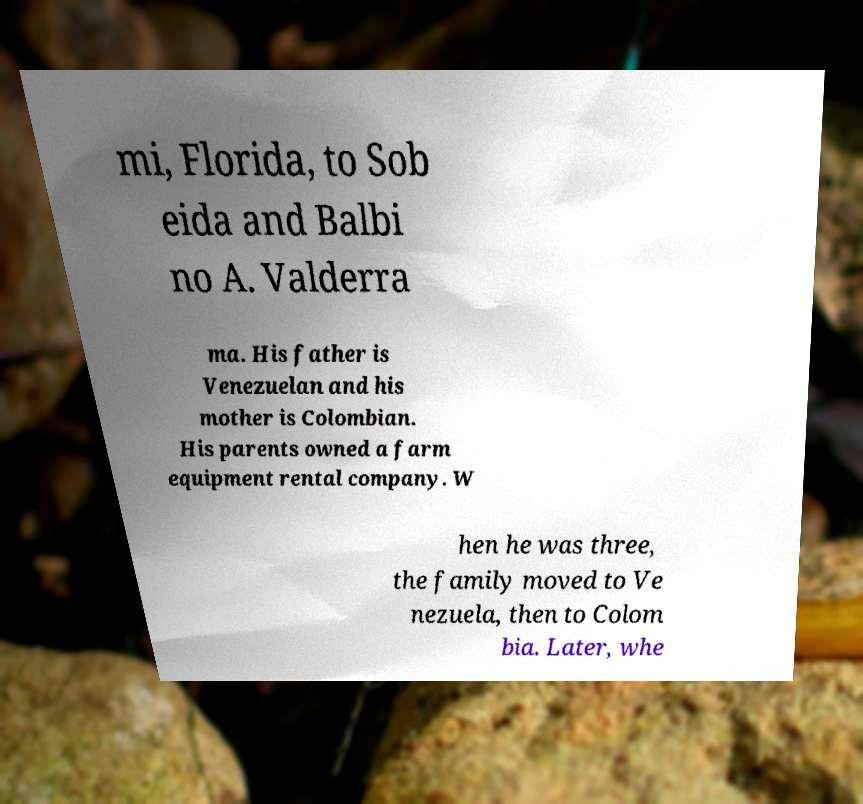Please identify and transcribe the text found in this image. mi, Florida, to Sob eida and Balbi no A. Valderra ma. His father is Venezuelan and his mother is Colombian. His parents owned a farm equipment rental company. W hen he was three, the family moved to Ve nezuela, then to Colom bia. Later, whe 